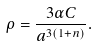Convert formula to latex. <formula><loc_0><loc_0><loc_500><loc_500>\rho = \frac { 3 \alpha C } { a ^ { 3 ( 1 + n ) } } .</formula> 